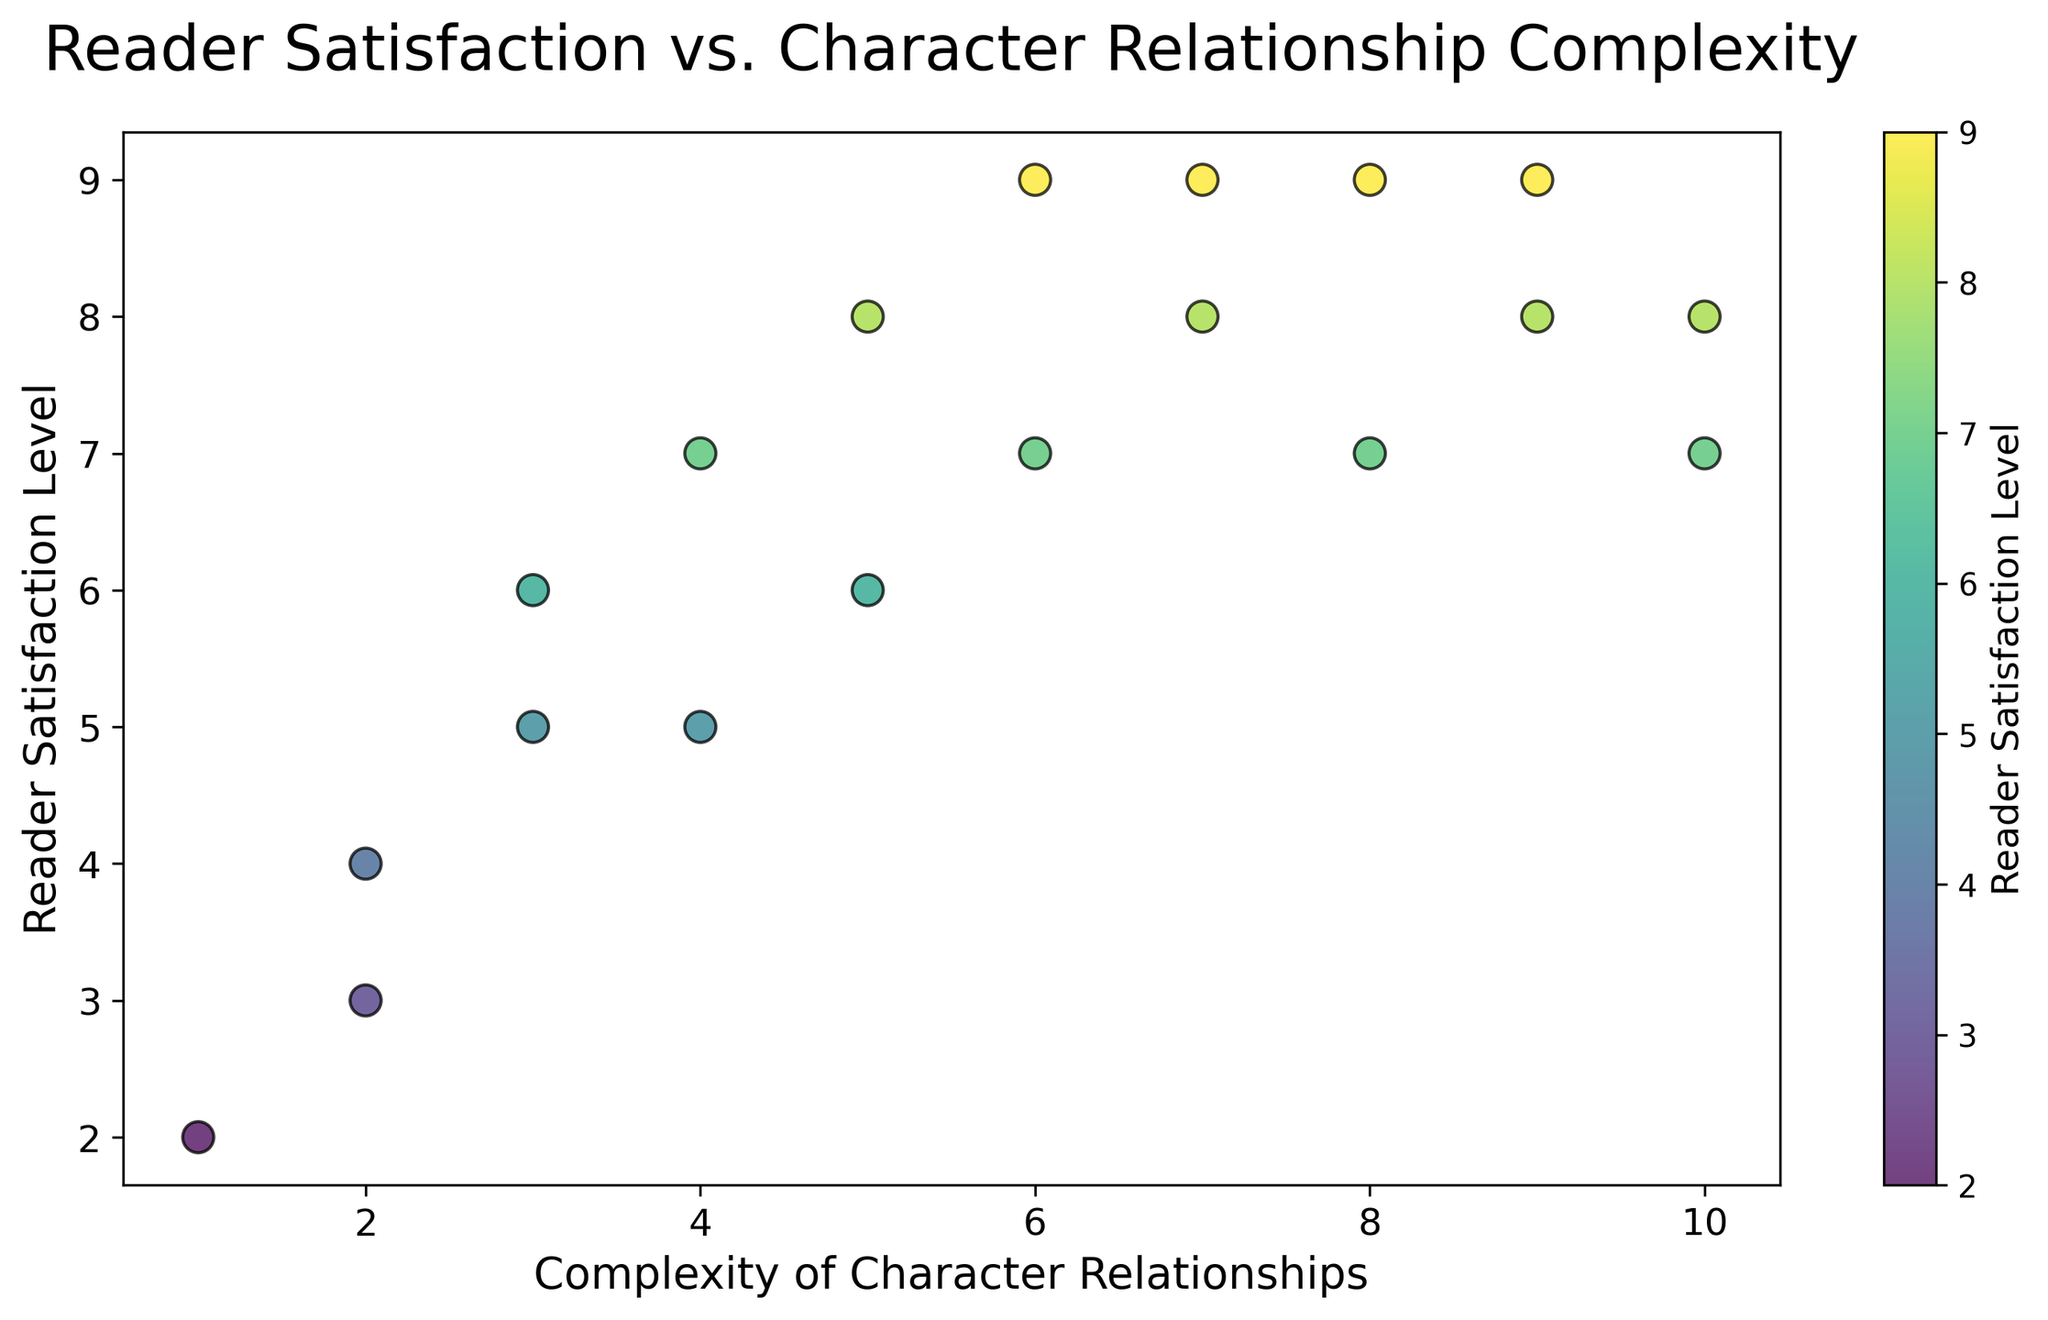What is the highest reader satisfaction level recorded in the figure? To find the highest reader satisfaction level, inspect all points on the scatter plot and identify the maximum value on the y-axis. The y-axis represents reader satisfaction, and the highest value shown is 9.
Answer: 9 What range of complexity in character relationships corresponds to the highest satisfaction level? First, identify the points where the satisfaction level is highest (9). Then, note the x-axis values for these points. Here, complexity levels 6, 7, 8, and 9 have a satisfaction level of 9.
Answer: 6 to 9 How does reader satisfaction change as character relationship complexity increases from 1 to 5? Observe the trend of points along the x-axis from 1 to 5. Reader satisfaction levels increase from 2 to 8, generally showing an upward trend.
Answer: Increases What is the average reader satisfaction level for character relationship complexities of 8 and higher? Look at points with complexity values of 8, 9, and 10. Their satisfaction levels are 7, 9, 8 (for 8); 8, 9 (for 9); and 7, 8 (for 10). Calculate the average: (7+9+8+8+9+7+8)/7 = 8.
Answer: 8 How many character relationships have a satisfaction level greater than or equal to 8? Count the points where the satisfaction level is 8 or 9. These levels appear at the complexities of 5, 6, 7, 8, 9, and 10. The total is 7.
Answer: 7 What is the difference in reader satisfaction between the highest and the lowest complexity of character relationships? Identify the satisfaction levels at complexity 1 (2) and 10 (7 and 8). The differences are 7-2 and 8-2, giving 5 and 6.
Answer: 5 or 6 Which complexity of character relationships has the widest range of reader satisfaction levels? Identify the complexity level with the most variation in satisfaction. Levels 2 and 10 range from 3 to 4 and 7 to 8. The widest range of satisfaction is from 5 to 9 (=2 and 3).
Answer: 2 or 10 What color predominates for the reader satisfaction level of 9? Note that a color bar indicates satisfaction with different colors. For satisfaction level 9, which appears at 6, 7, and 8 complexity, the color from the color bar is bright yellow-green.
Answer: yellow-green 